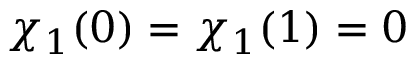<formula> <loc_0><loc_0><loc_500><loc_500>\chi _ { 1 } ( 0 ) = \chi _ { 1 } ( 1 ) = 0</formula> 